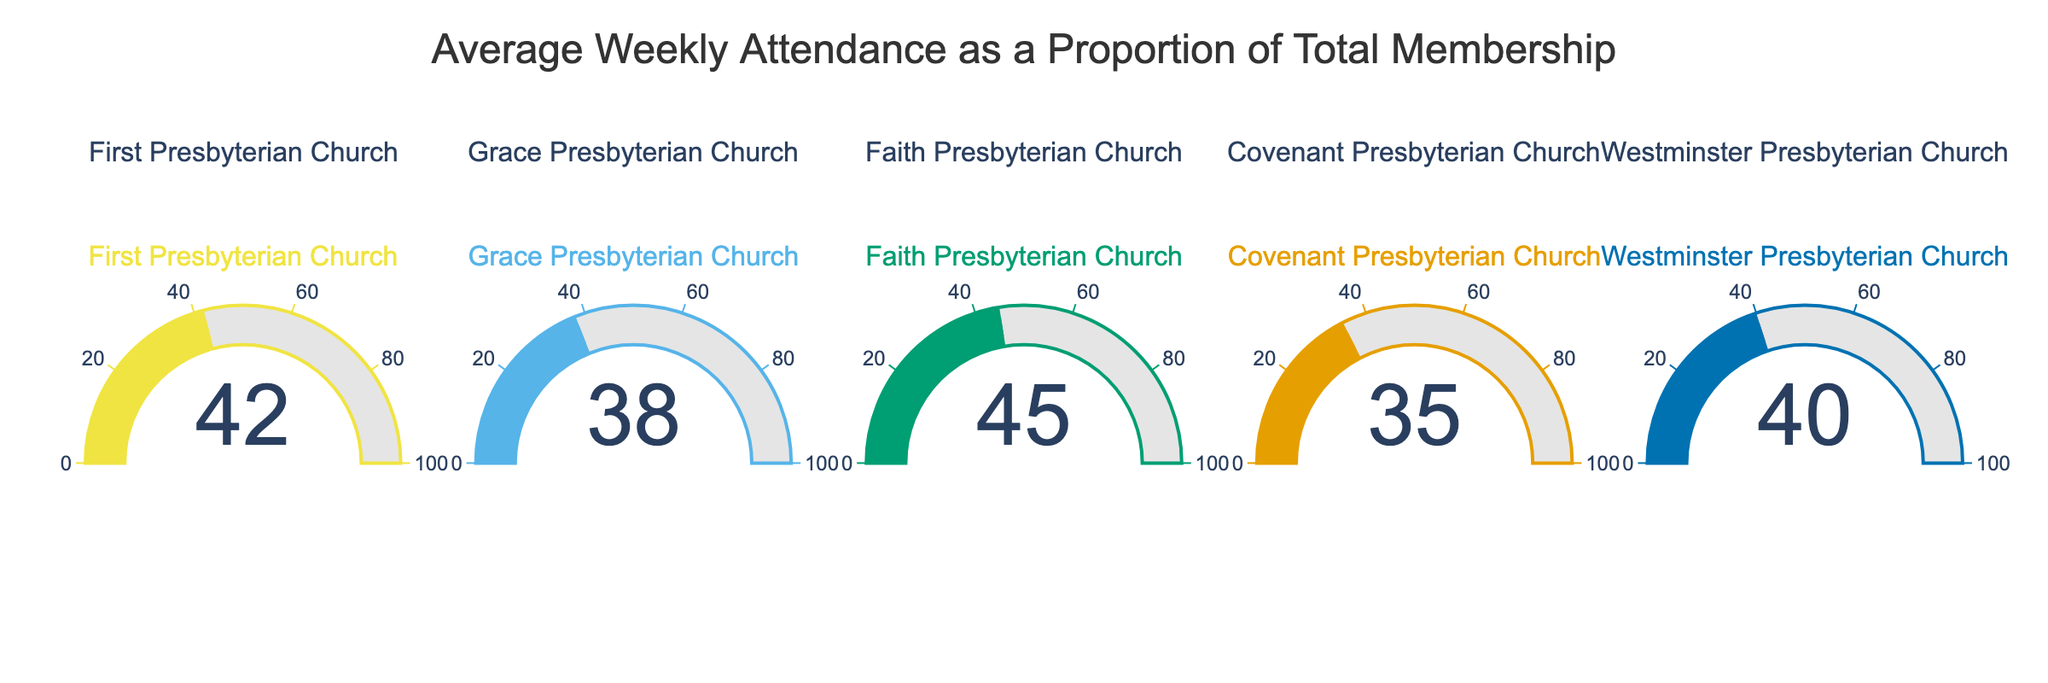What's the title of the figure? The title is displayed at the top of the figure. The title reads "Average Weekly Attendance as a Proportion of Total Membership".
Answer: Average Weekly Attendance as a Proportion of Total Membership How many churches are represented in the figure? Each gauge represents one church. Counting the number of gauges will give the number of churches. There are 5 gauges, which indicates 5 churches.
Answer: 5 Which church has the highest average weekly attendance percentage? By comparing the numbers displayed on each gauge, we find that Faith Presbyterian Church has the highest value at 45%.
Answer: Faith Presbyterian Church What is the attendance percentage for Westminster Presbyterian Church? We look at the gauge labeled "Westminster Presbyterian Church" and see the number displayed is 40%.
Answer: 40% Which church has an attendance percentage greater than 40%? We need to check each gauge to see which ones show a number greater than 40%. Faith Presbyterian Church has a value of 45%.
Answer: Faith Presbyterian Church What is the difference in attendance percentage between the church with the highest and lowest values? The highest value is 45% (Faith Presbyterian Church) and the lowest is 35% (Covenant Presbyterian Church). The difference is 45 - 35.
Answer: 10% What is the average attendance percentage of all the churches? Adding the percentages (42 + 38 + 45 + 35 + 40) and then dividing by the number of churches (5) gives the average. The sum is 200, so 200 / 5 = 40%.
Answer: 40% Which church has less than 40% attendance percentage? Checking each gauge, we find that Grace Presbyterian Church (38%) and Covenant Presbyterian Church (35%) have values less than 40%.
Answer: Grace Presbyterian Church and Covenant Presbyterian Church What is the combined attendance percentage of First Presbyterian Church and Covenant Presbyterian Church? Adding the percentages of these two churches, we get 42% (First) + 35% (Covenant) = 77%.
Answer: 77% By how much does the attendance percentage of First Presbyterian Church exceed that of Grace Presbyterian Church? Subtracting the percentage of Grace Presbyterian Church (38%) from that of First Presbyterian Church (42%) gives 42 - 38.
Answer: 4% 